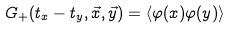Convert formula to latex. <formula><loc_0><loc_0><loc_500><loc_500>G _ { + } ( t _ { x } - t _ { y } , \vec { x } , \vec { y } ) = \langle \varphi ( x ) \varphi ( y ) \rangle</formula> 